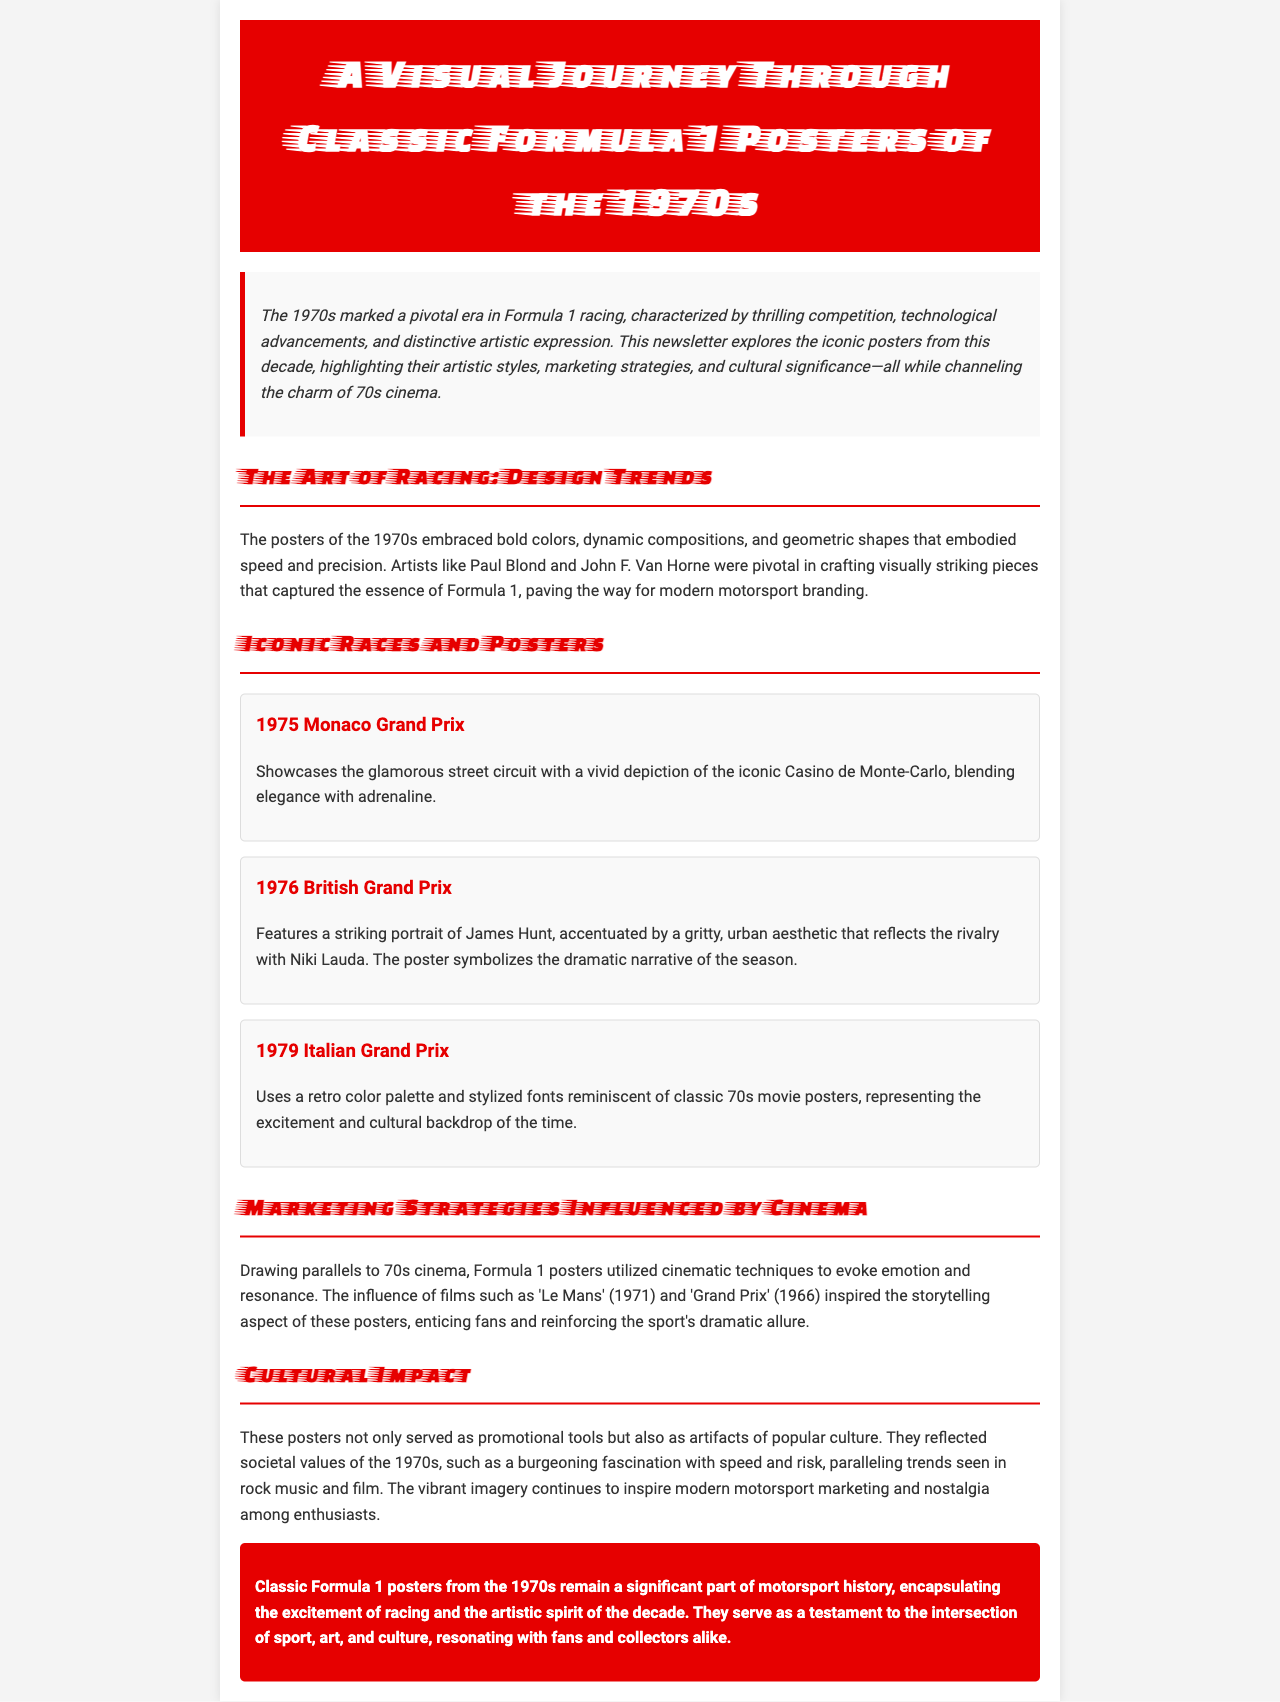what decade do the featured Formula 1 posters belong to? The document discusses Formula 1 posters from the 1970s.
Answer: 1970s who designed the poster for the 1976 British Grand Prix? The document mentions James Hunt along with his rivalry but does not specify an individual designer for this particular poster.
Answer: Not specified which race's poster features the Casino de Monte-Carlo? The document states that the poster for the 1975 Monaco Grand Prix showcases the Casino de Monte-Carlo.
Answer: 1975 Monaco Grand Prix name one film that influenced the marketing strategies of the posters. The document lists 'Le Mans' as an influential film in the context of the posters.
Answer: Le Mans what design elements were prominent in the 1970s Formula 1 posters? The document highlights bold colors, dynamic compositions, and geometric shapes as key design elements.
Answer: Bold colors, dynamic compositions, geometric shapes how do these posters reflect societal values of the 1970s? The document states that they reflect a fascination with speed and risk, paralleling trends in rock music and film.
Answer: Fascination with speed and risk what is the primary theme of the newsletter? The overarching theme focuses on a visual journey through classic Formula 1 posters from the 1970s.
Answer: A visual journey through classic Formula 1 posters what impact did the posters have on modern motorsport marketing? The document implies that the vibrant imagery continues to inspire modern motorsport marketing and nostalgia.
Answer: Inspiration for modern motorsport marketing 